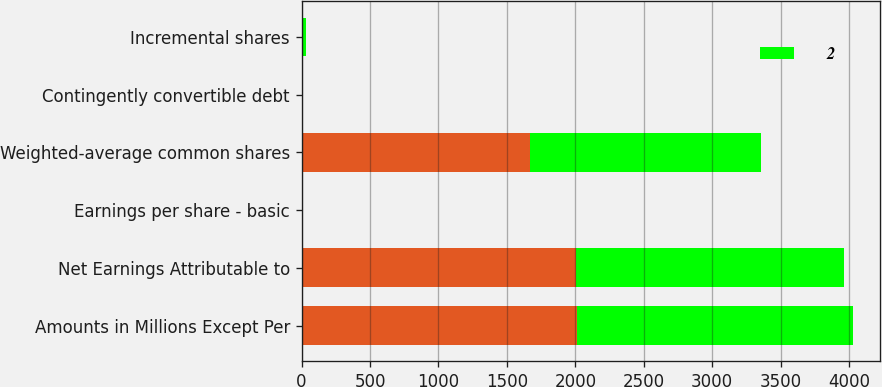Convert chart to OTSL. <chart><loc_0><loc_0><loc_500><loc_500><stacked_bar_chart><ecel><fcel>Amounts in Millions Except Per<fcel>Net Earnings Attributable to<fcel>Earnings per share - basic<fcel>Weighted-average common shares<fcel>Contingently convertible debt<fcel>Incremental shares<nl><fcel>nan<fcel>2014<fcel>2004<fcel>1.21<fcel>1670<fcel>1<fcel>12<nl><fcel>2<fcel>2012<fcel>1959<fcel>1.17<fcel>1688<fcel>1<fcel>17<nl></chart> 